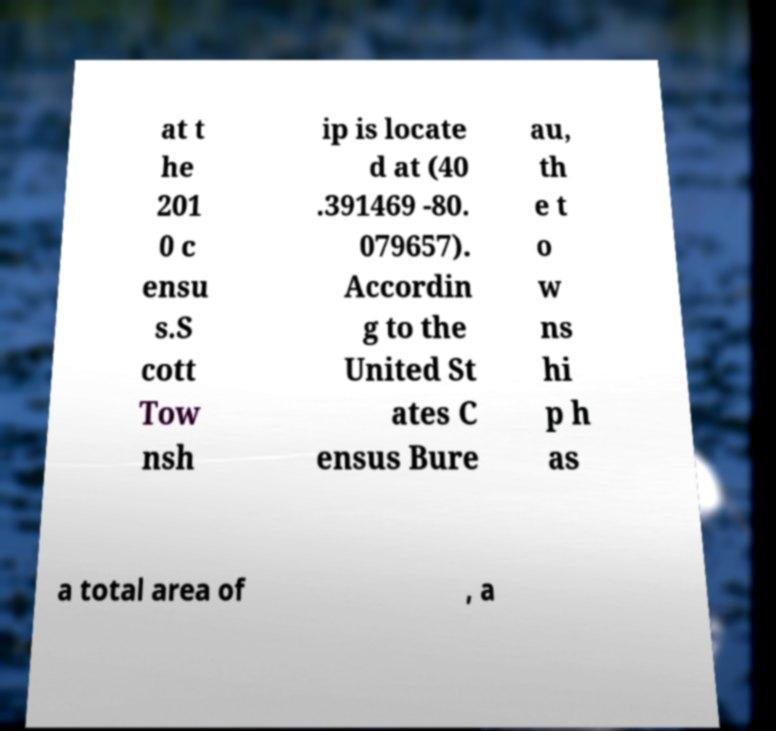For documentation purposes, I need the text within this image transcribed. Could you provide that? at t he 201 0 c ensu s.S cott Tow nsh ip is locate d at (40 .391469 -80. 079657). Accordin g to the United St ates C ensus Bure au, th e t o w ns hi p h as a total area of , a 